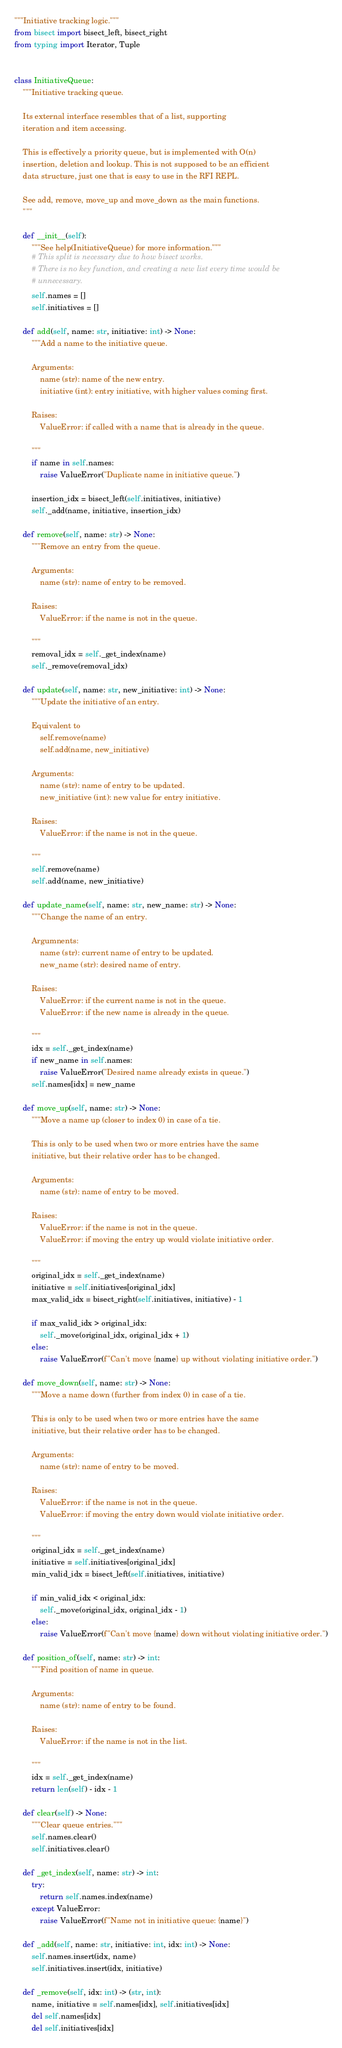<code> <loc_0><loc_0><loc_500><loc_500><_Python_>"""Initiative tracking logic."""
from bisect import bisect_left, bisect_right
from typing import Iterator, Tuple


class InitiativeQueue:
    """Initiative tracking queue.

    Its external interface resembles that of a list, supporting
    iteration and item accessing.

    This is effectively a priority queue, but is implemented with O(n)
    insertion, deletion and lookup. This is not supposed to be an efficient
    data structure, just one that is easy to use in the RFI REPL.

    See add, remove, move_up and move_down as the main functions.
    """

    def __init__(self):
        """See help(InitiativeQueue) for more information."""
        # This split is necessary due to how bisect works.
        # There is no key function, and creating a new list every time would be
        # unnecessary.
        self.names = []
        self.initiatives = []

    def add(self, name: str, initiative: int) -> None:
        """Add a name to the initiative queue.

        Arguments:
            name (str): name of the new entry.
            initiative (int): entry initiative, with higher values coming first.

        Raises:
            ValueError: if called with a name that is already in the queue.

        """
        if name in self.names:
            raise ValueError("Duplicate name in initiative queue.")

        insertion_idx = bisect_left(self.initiatives, initiative)
        self._add(name, initiative, insertion_idx)

    def remove(self, name: str) -> None:
        """Remove an entry from the queue.

        Arguments:
            name (str): name of entry to be removed.

        Raises:
            ValueError: if the name is not in the queue.

        """
        removal_idx = self._get_index(name)
        self._remove(removal_idx)

    def update(self, name: str, new_initiative: int) -> None:
        """Update the initiative of an entry.

        Equivalent to
            self.remove(name)
            self.add(name, new_initiative)

        Arguments:
            name (str): name of entry to be updated.
            new_initiative (int): new value for entry initiative.

        Raises:
            ValueError: if the name is not in the queue.

        """
        self.remove(name)
        self.add(name, new_initiative)

    def update_name(self, name: str, new_name: str) -> None:
        """Change the name of an entry.

        Argumnents:
            name (str): current name of entry to be updated.
            new_name (str): desired name of entry.

        Raises:
            ValueError: if the current name is not in the queue.
            ValueError: if the new name is already in the queue.

        """
        idx = self._get_index(name)
        if new_name in self.names:
            raise ValueError("Desired name already exists in queue.")
        self.names[idx] = new_name

    def move_up(self, name: str) -> None:
        """Move a name up (closer to index 0) in case of a tie.

        This is only to be used when two or more entries have the same
        initiative, but their relative order has to be changed.

        Arguments:
            name (str): name of entry to be moved.

        Raises:
            ValueError: if the name is not in the queue.
            ValueError: if moving the entry up would violate initiative order.

        """
        original_idx = self._get_index(name)
        initiative = self.initiatives[original_idx]
        max_valid_idx = bisect_right(self.initiatives, initiative) - 1

        if max_valid_idx > original_idx:
            self._move(original_idx, original_idx + 1)
        else:
            raise ValueError(f"Can't move {name} up without violating initiative order.")

    def move_down(self, name: str) -> None:
        """Move a name down (further from index 0) in case of a tie.

        This is only to be used when two or more entries have the same
        initiative, but their relative order has to be changed.

        Arguments:
            name (str): name of entry to be moved.

        Raises:
            ValueError: if the name is not in the queue.
            ValueError: if moving the entry down would violate initiative order.

        """
        original_idx = self._get_index(name)
        initiative = self.initiatives[original_idx]
        min_valid_idx = bisect_left(self.initiatives, initiative)

        if min_valid_idx < original_idx:
            self._move(original_idx, original_idx - 1)
        else:
            raise ValueError(f"Can't move {name} down without violating initiative order.")

    def position_of(self, name: str) -> int:
        """Find position of name in queue.

        Arguments:
            name (str): name of entry to be found.

        Raises:
            ValueError: if the name is not in the list.

        """
        idx = self._get_index(name)
        return len(self) - idx - 1

    def clear(self) -> None:
        """Clear queue entries."""
        self.names.clear()
        self.initiatives.clear()

    def _get_index(self, name: str) -> int:
        try:
            return self.names.index(name)
        except ValueError:
            raise ValueError(f"Name not in initiative queue: {name}")

    def _add(self, name: str, initiative: int, idx: int) -> None:
        self.names.insert(idx, name)
        self.initiatives.insert(idx, initiative)

    def _remove(self, idx: int) -> (str, int):
        name, initiative = self.names[idx], self.initiatives[idx]
        del self.names[idx]
        del self.initiatives[idx]</code> 